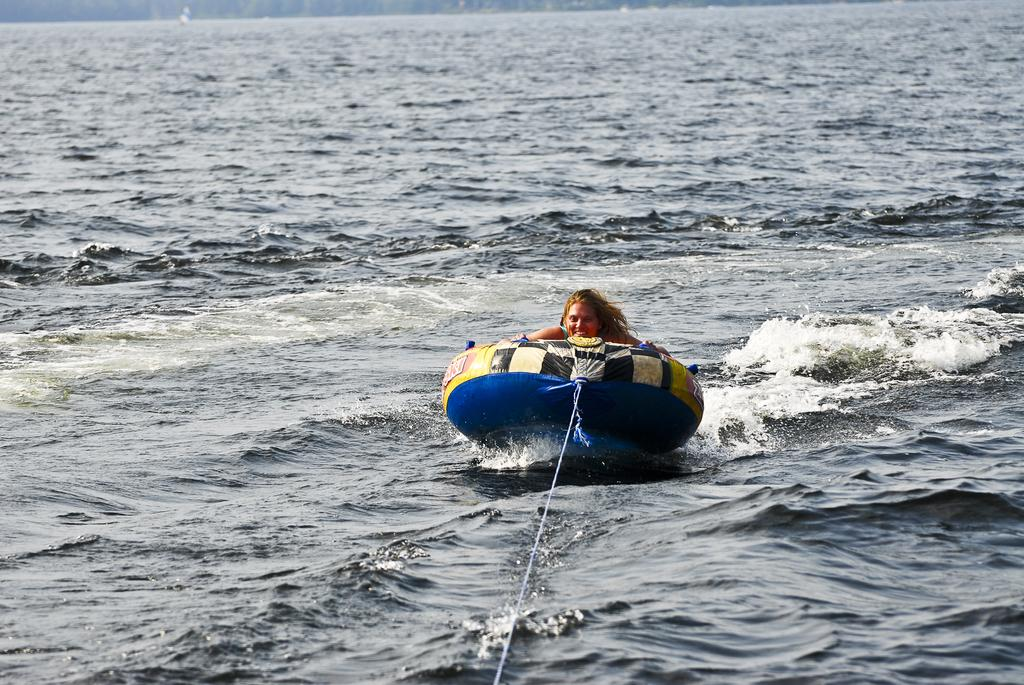Who is present in the image? There is a woman in the image. What is the woman doing in the image? The woman is on an object. What is the object on which the woman is sitting? The object is on the water. Is there any connection between the object and its surroundings? Yes, there is a rope tightened to the object. What type of feather can be seen floating near the woman in the image? There is no feather visible in the image. What kind of iron is being used to hold the object in place? There is no iron present in the image; the object is connected to its surroundings by a rope. 